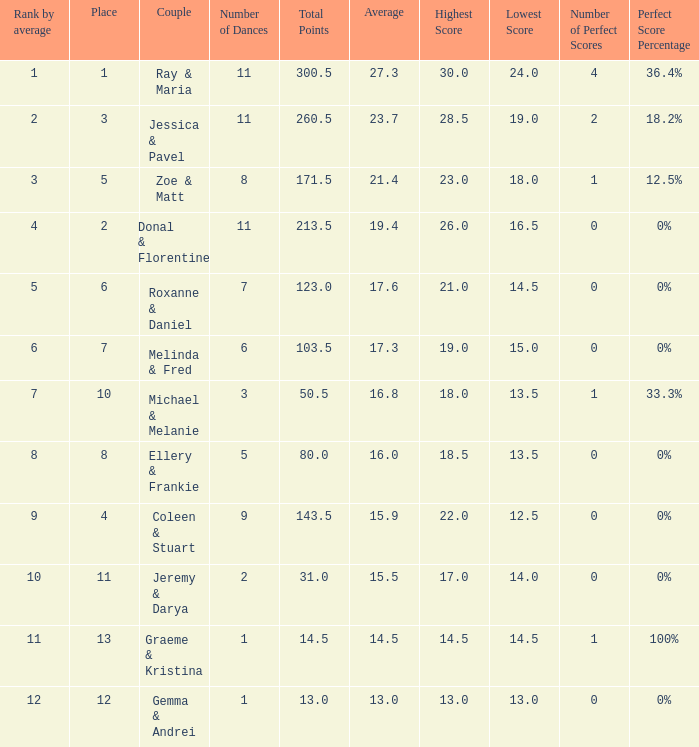If the total points is 50.5, what is the total number of dances? 1.0. 